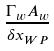Convert formula to latex. <formula><loc_0><loc_0><loc_500><loc_500>\frac { \Gamma _ { w } A _ { w } } { { \delta x } _ { W P } }</formula> 